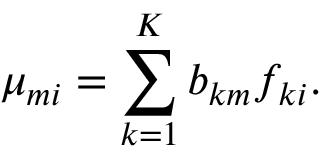Convert formula to latex. <formula><loc_0><loc_0><loc_500><loc_500>\mu _ { m i } = \sum _ { k = 1 } ^ { K } b _ { k m } f _ { k i } .</formula> 